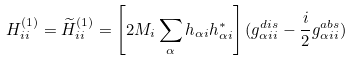<formula> <loc_0><loc_0><loc_500><loc_500>H _ { i i } ^ { ( 1 ) } = \widetilde { H } _ { i i } ^ { ( 1 ) } = \left [ 2 M _ { i } \sum _ { \alpha } h _ { \alpha i } h _ { \alpha i } ^ { \ast } \right ] ( g _ { \alpha i i } ^ { d i s } - \frac { i } { 2 } g _ { \alpha i i } ^ { a b s } )</formula> 